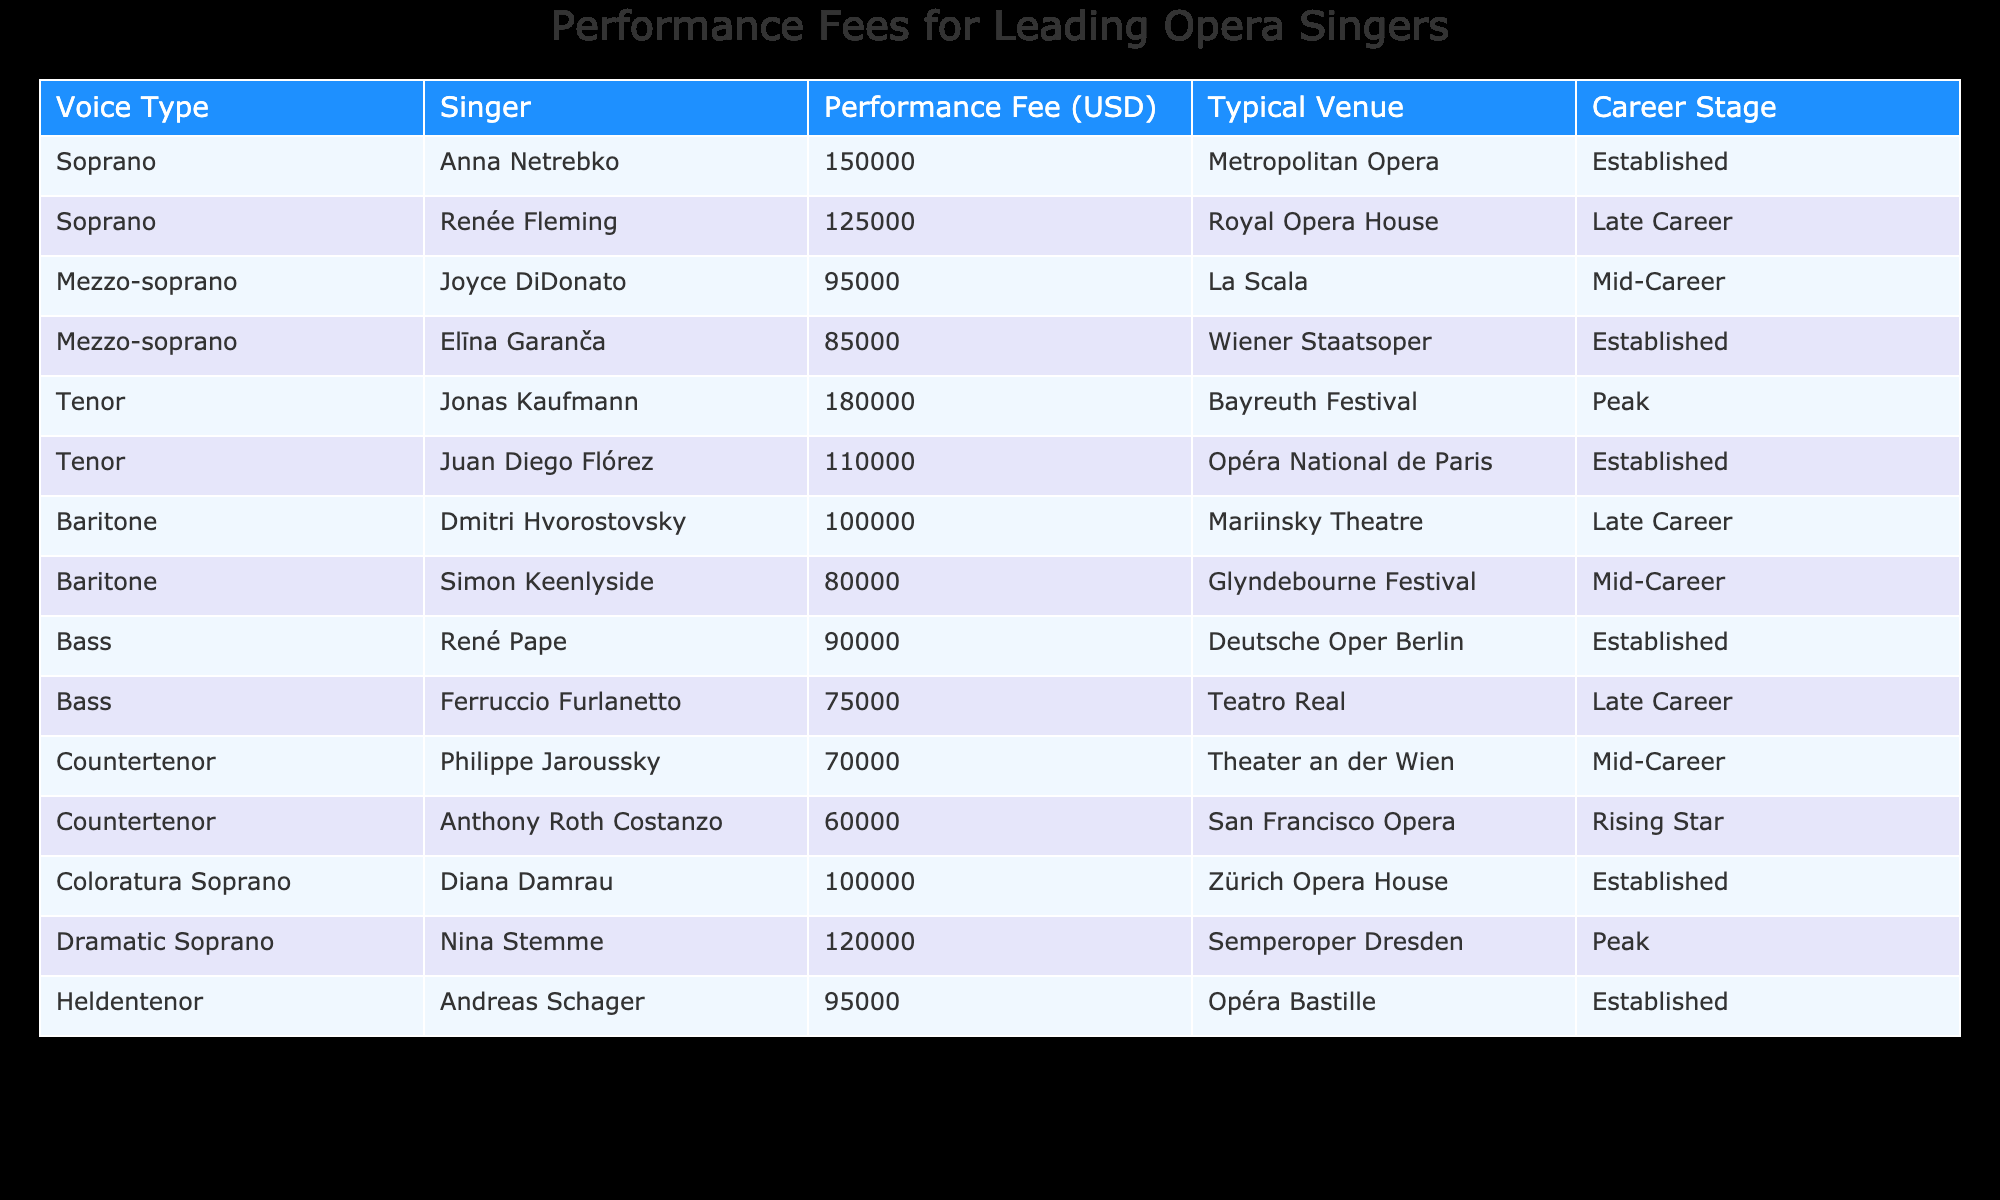What is the highest performance fee among these singers? The highest performance fee listed in the table is for Jonas Kaufmann, who charges 180,000 USD.
Answer: 180,000 USD Which tenor has the lowest performance fee? Among the tenors, Anthony Roth Costanzo has the lowest performance fee at 60,000 USD.
Answer: 60,000 USD How much more does Anna Netrebko charge than Elīna Garanča? Anna Netrebko's performance fee is 150,000 USD, while Elīna Garanča's fee is 85,000 USD. The difference is 150,000 - 85,000 = 65,000 USD.
Answer: 65,000 USD Is there a countertenor with a performance fee higher than 70,000 USD? Yes, Philippe Jaroussky has a performance fee of 70,000 USD, which meets the criteria. Therefore, the answer is yes.
Answer: Yes What is the average performance fee for mezzosopranos in this table? The performance fees for mezzosopranos are 95,000 USD (Joyce DiDonato) and 85,000 USD (Elīna Garanča). The average is (95,000 + 85,000) / 2 = 90,000 USD.
Answer: 90,000 USD Which voice type has the highest established career stage fee? Comparing established singers, Anna Netrebko with 150,000 USD and Elīna Garanča with 85,000 USD, Anna Netrebko has the highest fee of 150,000 USD.
Answer: 150,000 USD Are there any baritones who charge less than 90,000 USD? Yes, Simon Keenlyside has a performance fee of 80,000 USD, which is less than 90,000 USD.
Answer: Yes What is the combined performance fee of all the bass singers? The fees for bass singers are 90,000 USD (René Pape) and 75,000 USD (Ferruccio Furlanetto). Their combined fee is 90,000 + 75,000 = 165,000 USD.
Answer: 165,000 USD 